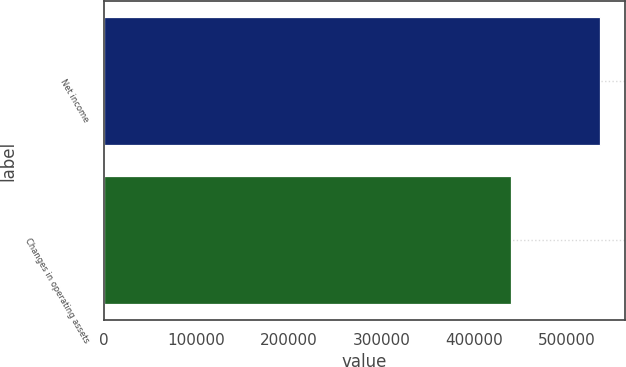Convert chart to OTSL. <chart><loc_0><loc_0><loc_500><loc_500><bar_chart><fcel>Net income<fcel>Changes in operating assets<nl><fcel>536017<fcel>439200<nl></chart> 